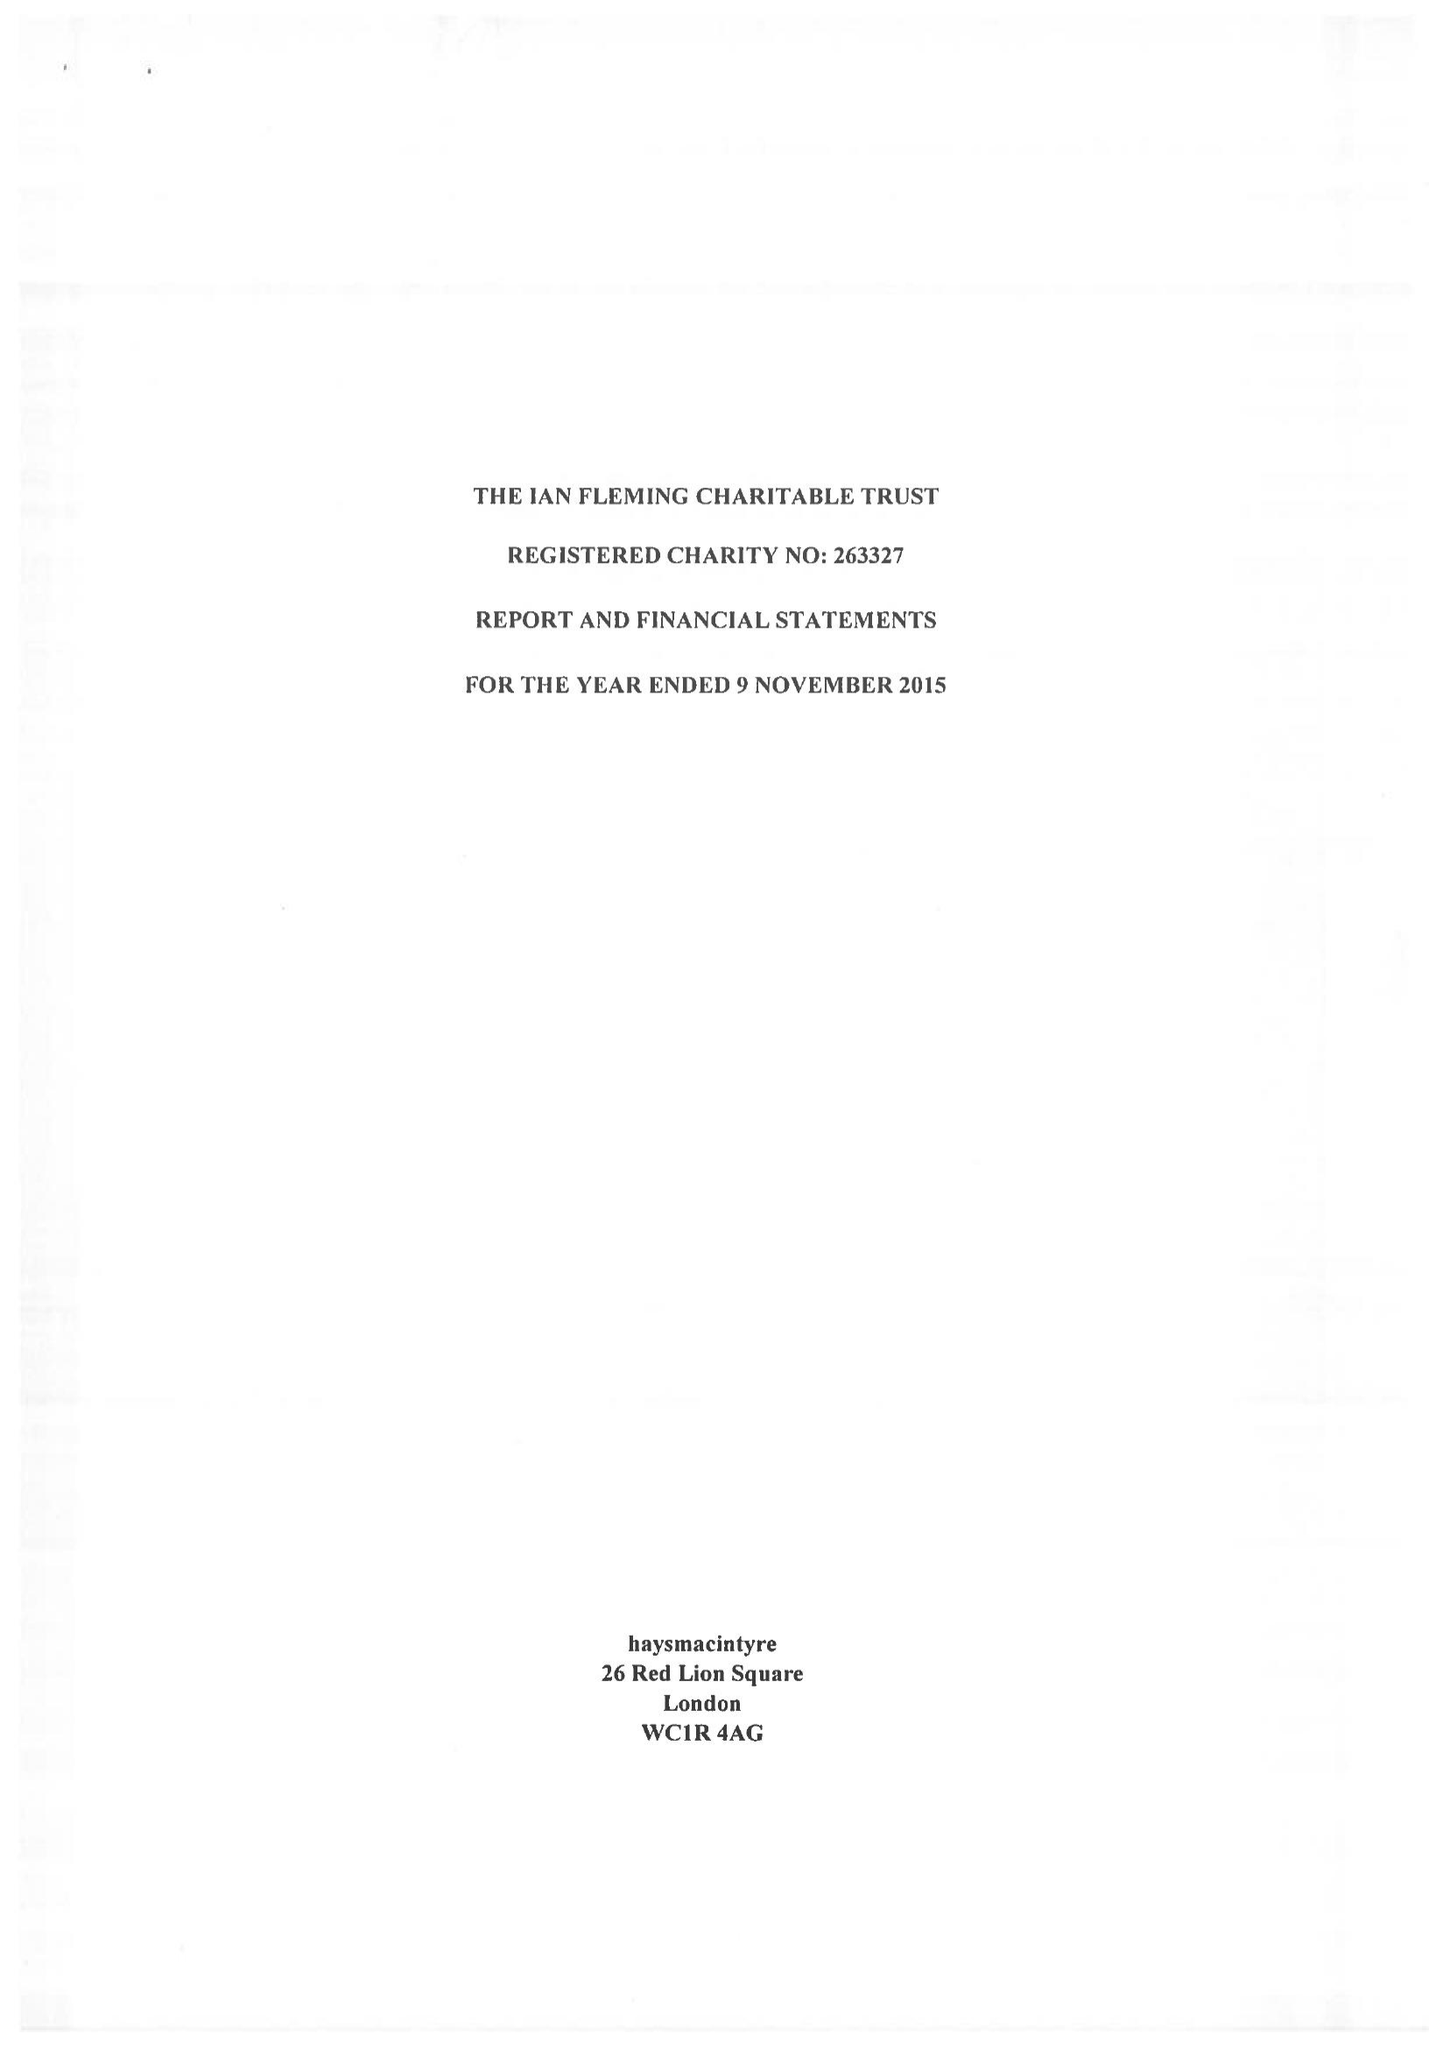What is the value for the spending_annually_in_british_pounds?
Answer the question using a single word or phrase. 56999.00 